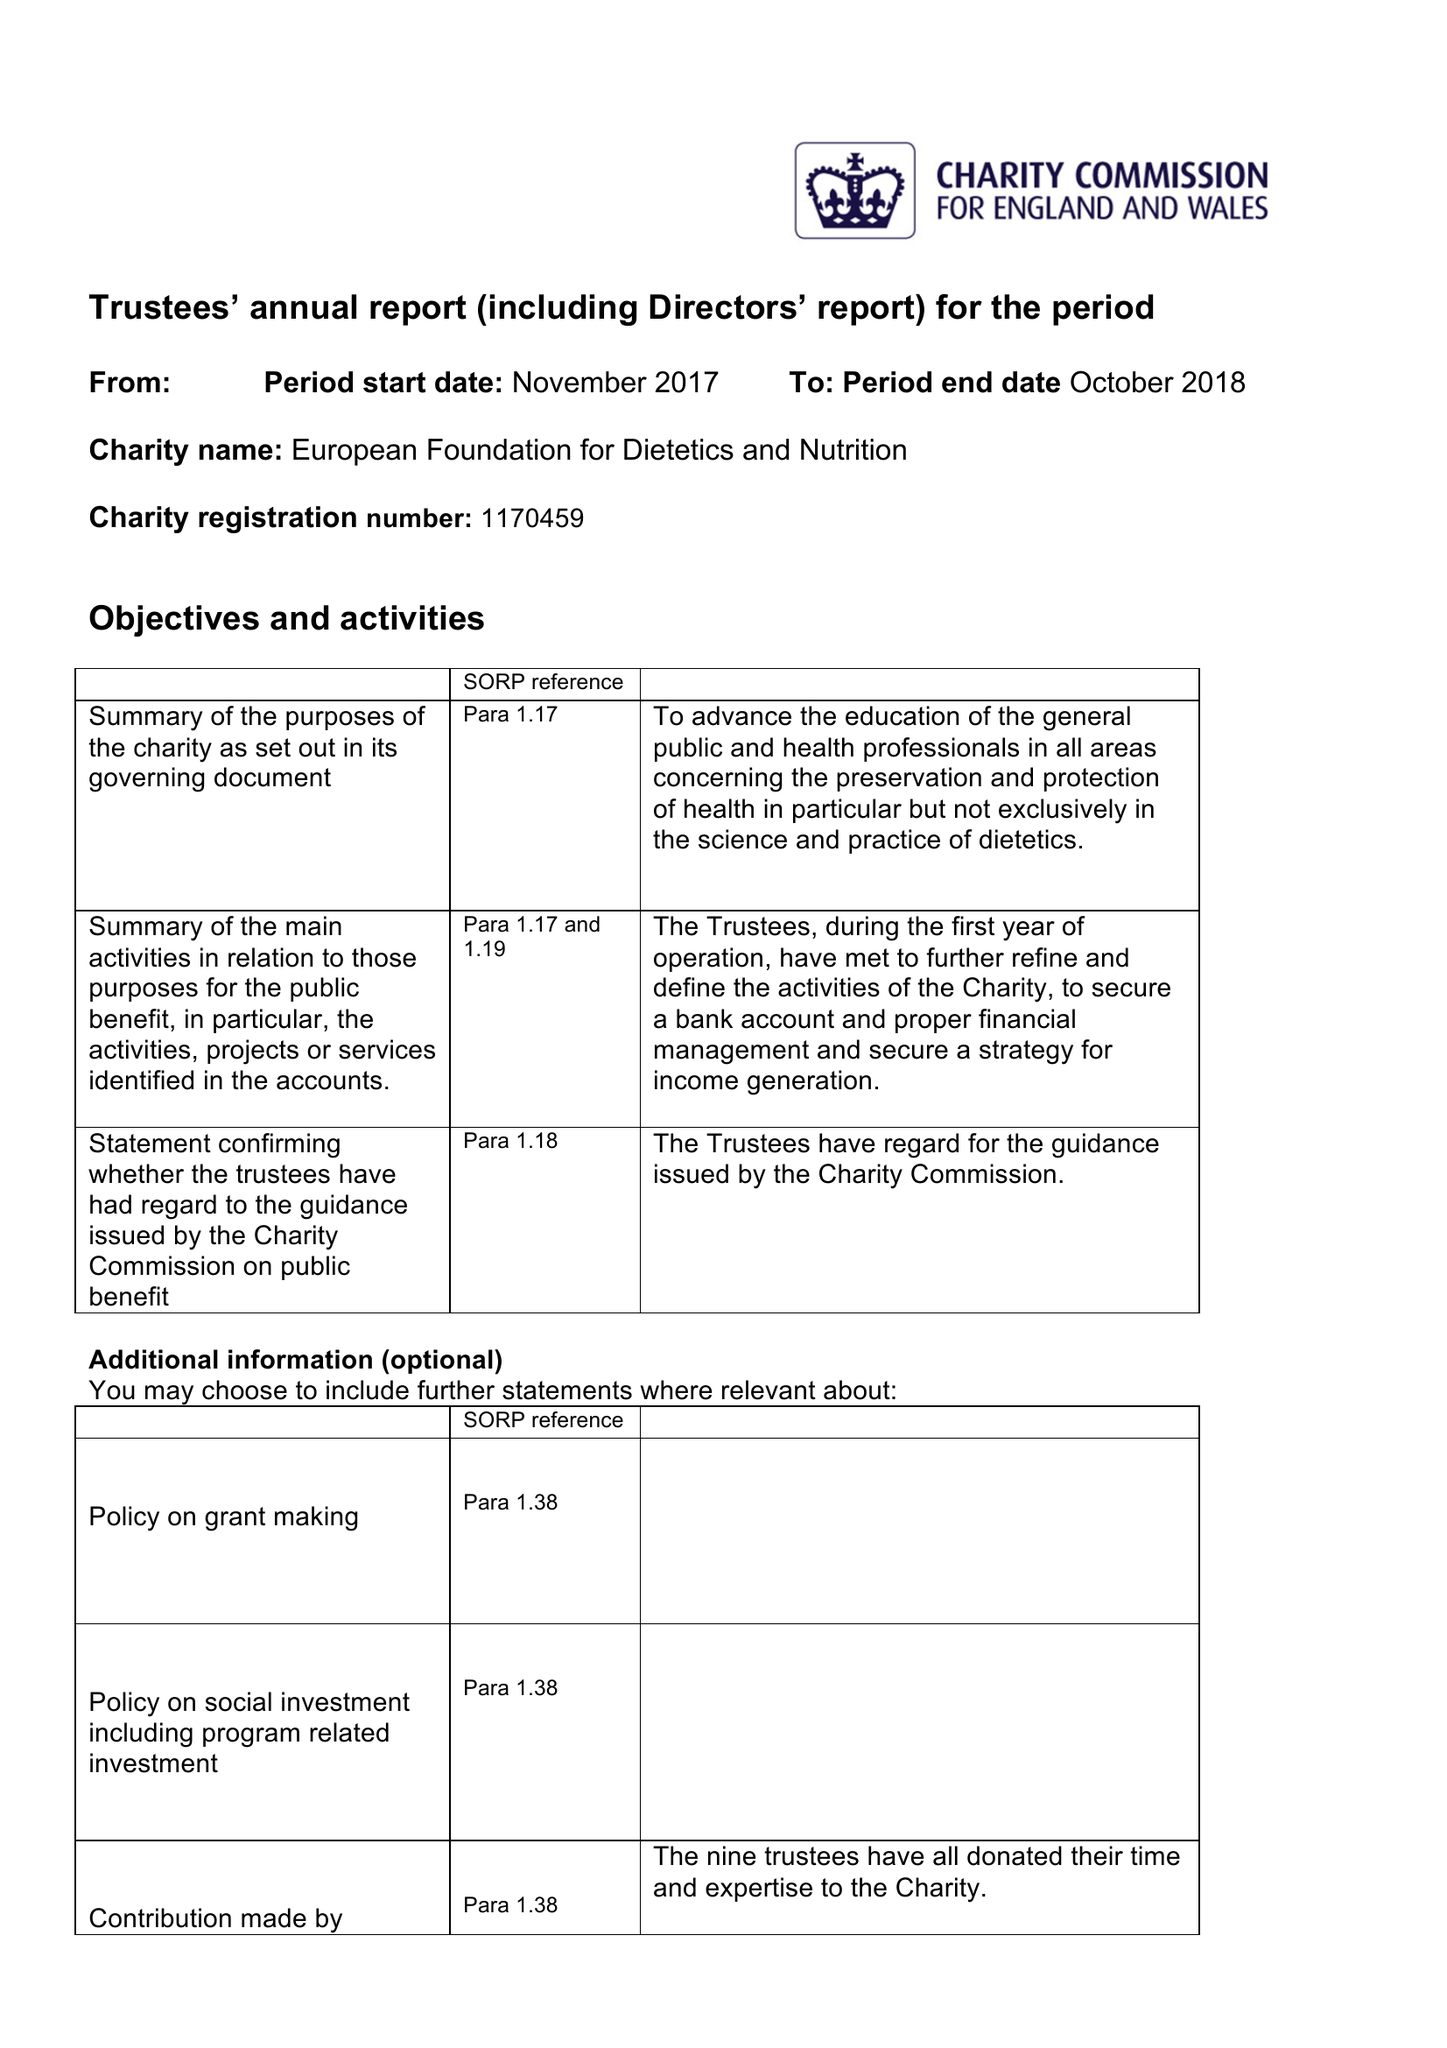What is the value for the spending_annually_in_british_pounds?
Answer the question using a single word or phrase. None 